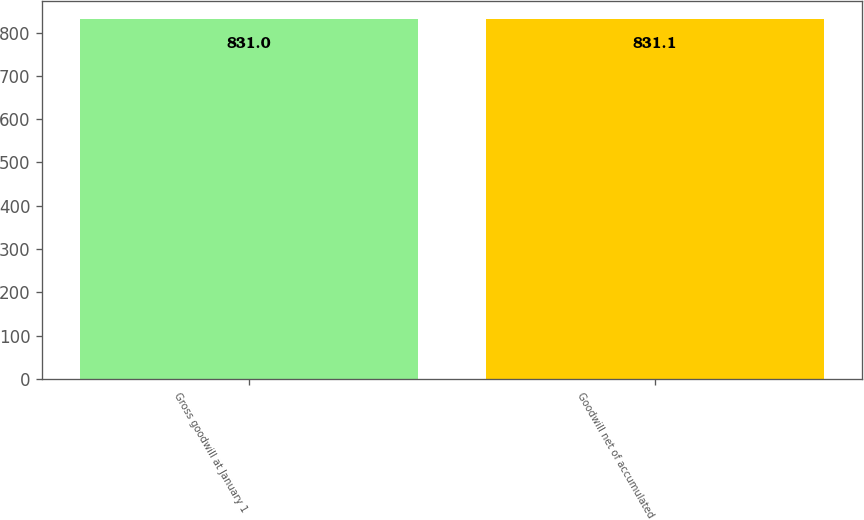Convert chart to OTSL. <chart><loc_0><loc_0><loc_500><loc_500><bar_chart><fcel>Gross goodwill at January 1<fcel>Goodwill net of accumulated<nl><fcel>831<fcel>831.1<nl></chart> 